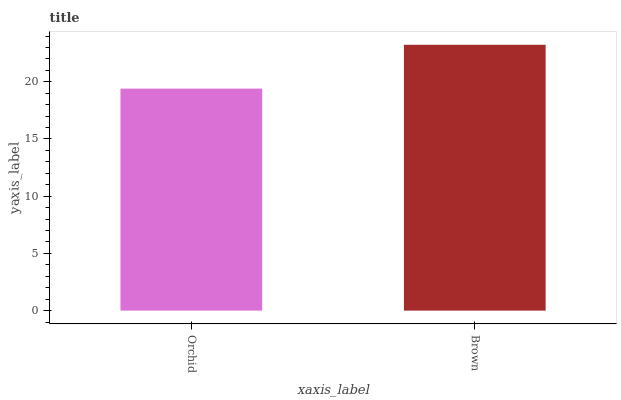Is Orchid the minimum?
Answer yes or no. Yes. Is Brown the maximum?
Answer yes or no. Yes. Is Brown the minimum?
Answer yes or no. No. Is Brown greater than Orchid?
Answer yes or no. Yes. Is Orchid less than Brown?
Answer yes or no. Yes. Is Orchid greater than Brown?
Answer yes or no. No. Is Brown less than Orchid?
Answer yes or no. No. Is Brown the high median?
Answer yes or no. Yes. Is Orchid the low median?
Answer yes or no. Yes. Is Orchid the high median?
Answer yes or no. No. Is Brown the low median?
Answer yes or no. No. 